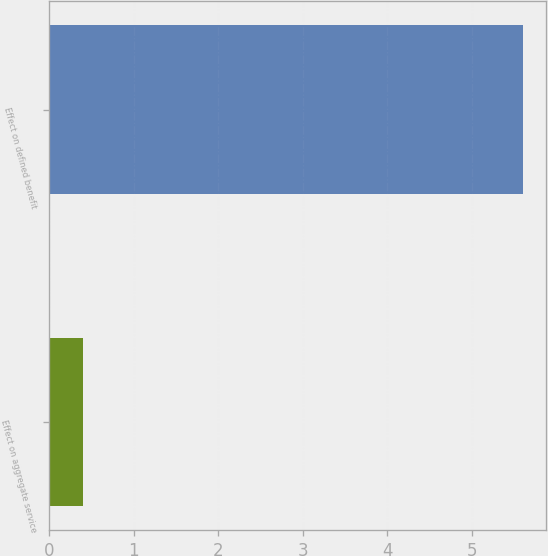Convert chart to OTSL. <chart><loc_0><loc_0><loc_500><loc_500><bar_chart><fcel>Effect on aggregate service<fcel>Effect on defined benefit<nl><fcel>0.4<fcel>5.6<nl></chart> 